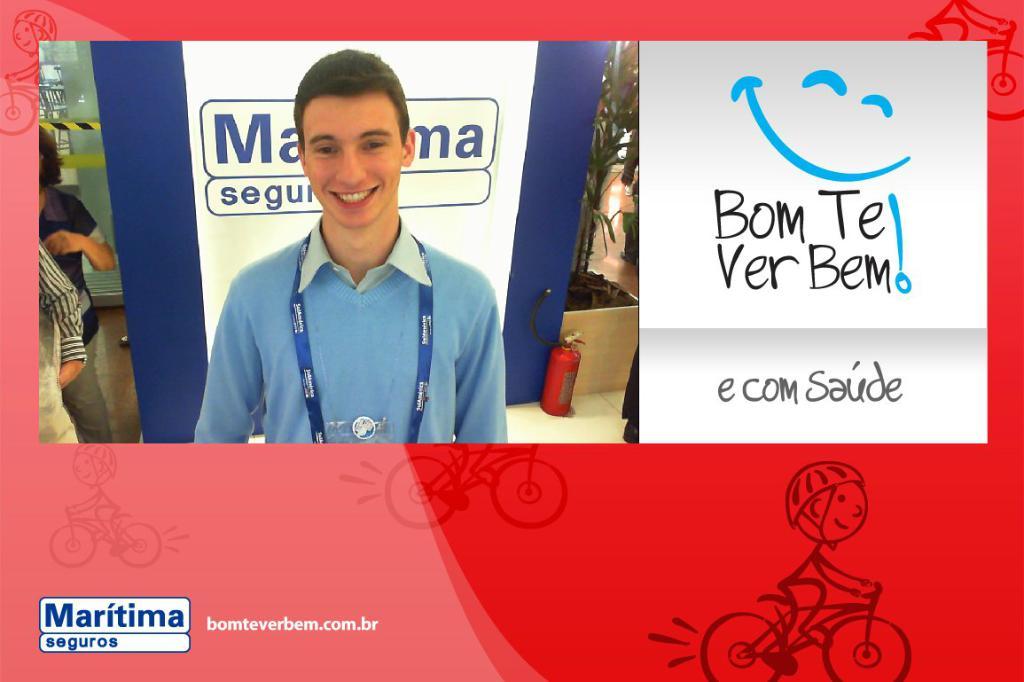What is the website associated with this ad?
Offer a terse response. Bomteverbem.com.br. What does the text under the smile say?
Ensure brevity in your answer.  Bom te ver bem. 